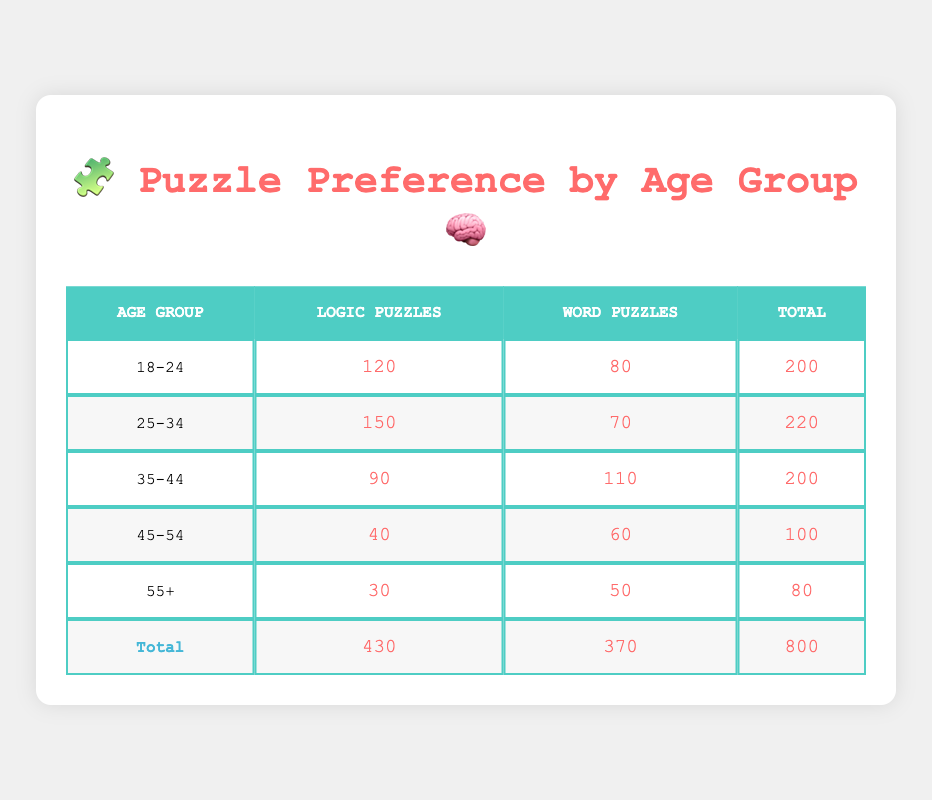What is the total number of participants in the 18-24 age group? The table shows that there are 120 participants who prefer Logic Puzzles and 80 who prefer Word Puzzles in the 18-24 age group. To find the total, we add these two numbers: 120 + 80 = 200.
Answer: 200 Which age group has the highest preference for Word Puzzles? By reviewing the counts for Word Puzzles in each age group, we see that the 35-44 age group has 110 participants. All other groups have lower counts for Word Puzzles. Therefore, the 35-44 age group has the highest preference.
Answer: 35-44 How many more participants prefer Logic Puzzles compared to Word Puzzles for the 25-34 age group? Looking at the 25-34 age group, we have 150 preferring Logic Puzzles and 70 preferring Word Puzzles. We subtract the number of Word Puzzle participants from Logic Puzzle participants: 150 - 70 = 80.
Answer: 80 Is it true that more participants in the 45-54 age group prefer Logic Puzzles than those in the 55+ age group? In the 45-54 age group, 40 participants prefer Logic Puzzles, while in the 55+ age group, only 30 prefer Logic Puzzles. Since 40 is greater than 30, the statement is true.
Answer: Yes What is the average number of Logic Puzzle participants across all age groups? We first sum the counts of Logic Puzzle participants: 120 (18-24) + 150 (25-34) + 90 (35-44) + 40 (45-54) + 30 (55+) = 430. Since there are 5 age groups, we divide by 5 to find the average: 430 / 5 = 86.
Answer: 86 Which age group has the lowest total number of participants? By inspecting the total counts for each age group, the 55+ age group has the lowest total with 80 participants (30 for Logic + 50 for Word).
Answer: 55+ Are there more participants overall who prefer Logic Puzzles than Word Puzzles? The total number of participants for Logic Puzzles is 430 and for Word Puzzles is 370. Since 430 is greater than 370, the statement is true.
Answer: Yes What is the combined total number of participants in the 25-34 and 35-44 age groups? For the 25-34 age group, the total is 220 (150 Logic + 70 Word) and for the 35-44 age group, it is 200 (90 Logic + 110 Word). Adding these totals gives us: 220 + 200 = 420.
Answer: 420 